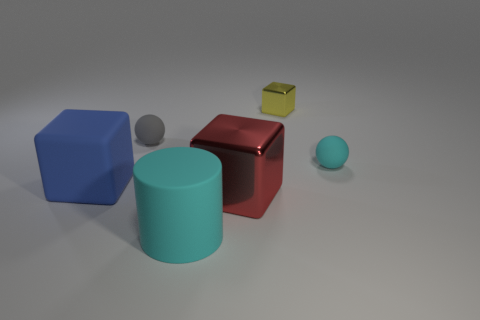What is the thing that is right of the shiny object that is behind the gray matte thing made of?
Provide a succinct answer. Rubber. Are there any red objects made of the same material as the cylinder?
Your answer should be compact. No. What is the shape of the tiny rubber object that is on the right side of the small thing on the left side of the small block behind the blue matte thing?
Offer a terse response. Sphere. What is the material of the small block?
Keep it short and to the point. Metal. The big cylinder that is made of the same material as the large blue object is what color?
Ensure brevity in your answer.  Cyan. Is there a small yellow metal cube behind the matte object right of the large cyan thing?
Ensure brevity in your answer.  Yes. What number of other objects are the same shape as the tiny metal object?
Provide a succinct answer. 2. There is a rubber object to the right of the yellow cube; is it the same shape as the big object that is to the left of the big cyan matte cylinder?
Provide a succinct answer. No. What number of small cyan balls are right of the matte ball that is left of the rubber object that is to the right of the yellow metallic thing?
Keep it short and to the point. 1. The rubber cube is what color?
Provide a short and direct response. Blue. 